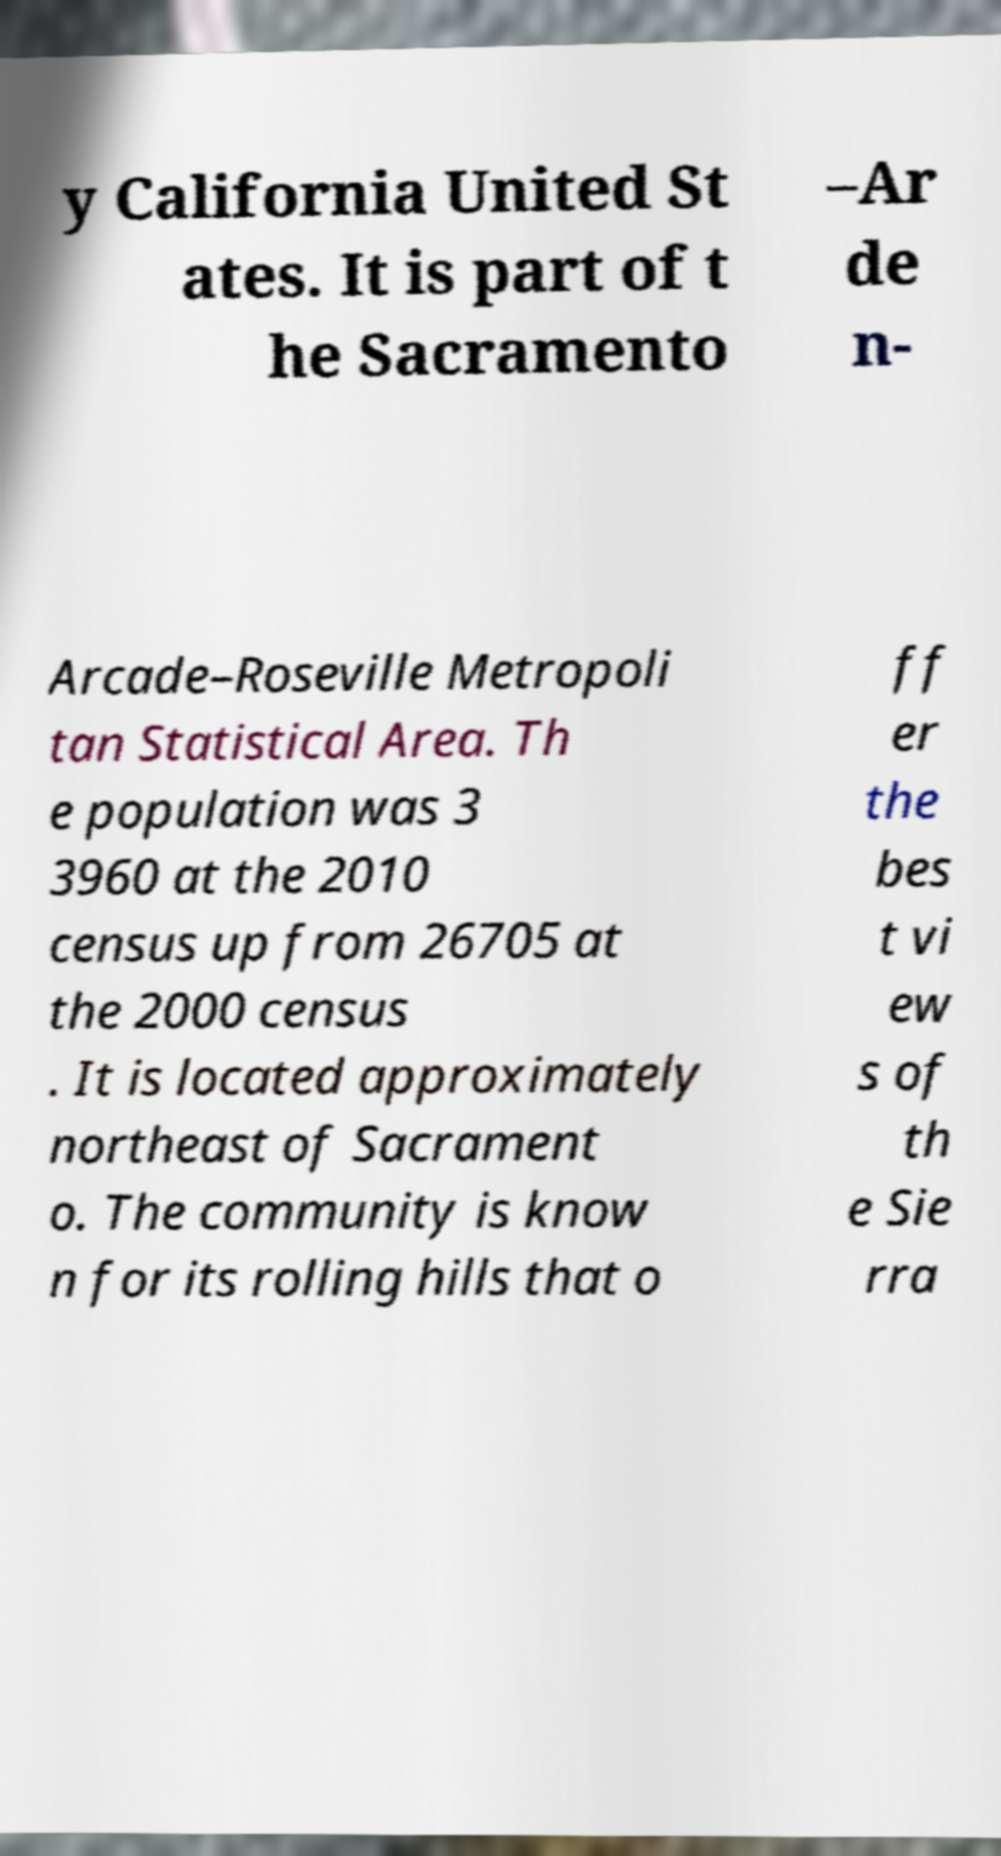For documentation purposes, I need the text within this image transcribed. Could you provide that? y California United St ates. It is part of t he Sacramento –Ar de n- Arcade–Roseville Metropoli tan Statistical Area. Th e population was 3 3960 at the 2010 census up from 26705 at the 2000 census . It is located approximately northeast of Sacrament o. The community is know n for its rolling hills that o ff er the bes t vi ew s of th e Sie rra 